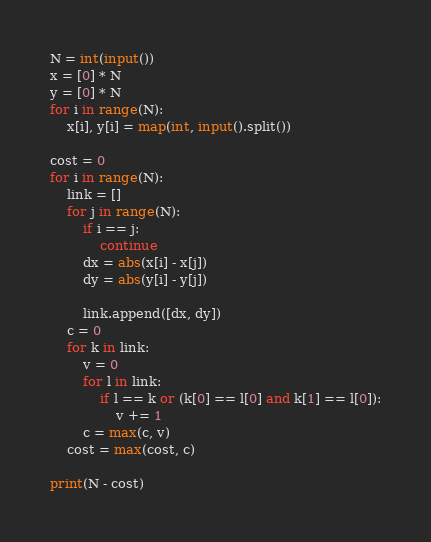<code> <loc_0><loc_0><loc_500><loc_500><_Python_>N = int(input())
x = [0] * N
y = [0] * N
for i in range(N):
    x[i], y[i] = map(int, input().split())

cost = 0
for i in range(N):
    link = []
    for j in range(N):
        if i == j:
            continue
        dx = abs(x[i] - x[j])
        dy = abs(y[i] - y[j])

        link.append([dx, dy])
    c = 0
    for k in link:
        v = 0
        for l in link:
            if l == k or (k[0] == l[0] and k[1] == l[0]):
                v += 1
        c = max(c, v)        
    cost = max(cost, c)

print(N - cost)
</code> 